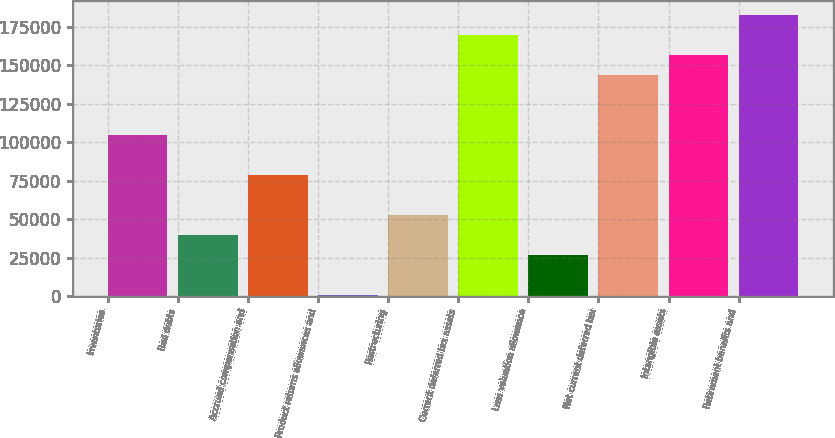Convert chart. <chart><loc_0><loc_0><loc_500><loc_500><bar_chart><fcel>Inventories<fcel>Bad debts<fcel>Accrued compensation and<fcel>Product returns allowances and<fcel>Restructuring<fcel>Current deferred tax assets<fcel>Less valuation allowance<fcel>Net current deferred tax<fcel>Intangible assets<fcel>Retirement benefits and<nl><fcel>104850<fcel>39747.5<fcel>78809<fcel>686<fcel>52768<fcel>169952<fcel>26727<fcel>143912<fcel>156932<fcel>182973<nl></chart> 